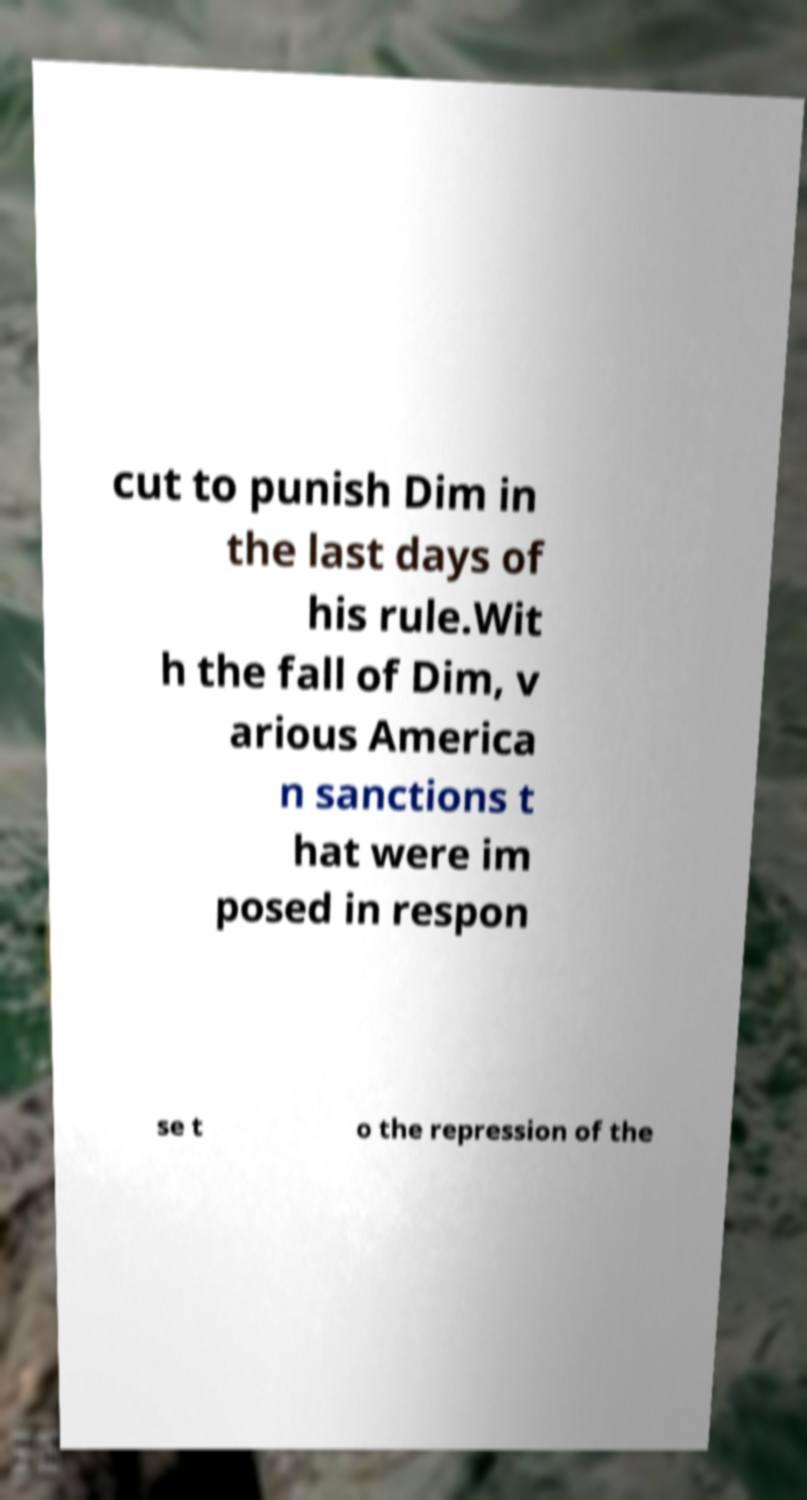I need the written content from this picture converted into text. Can you do that? cut to punish Dim in the last days of his rule.Wit h the fall of Dim, v arious America n sanctions t hat were im posed in respon se t o the repression of the 